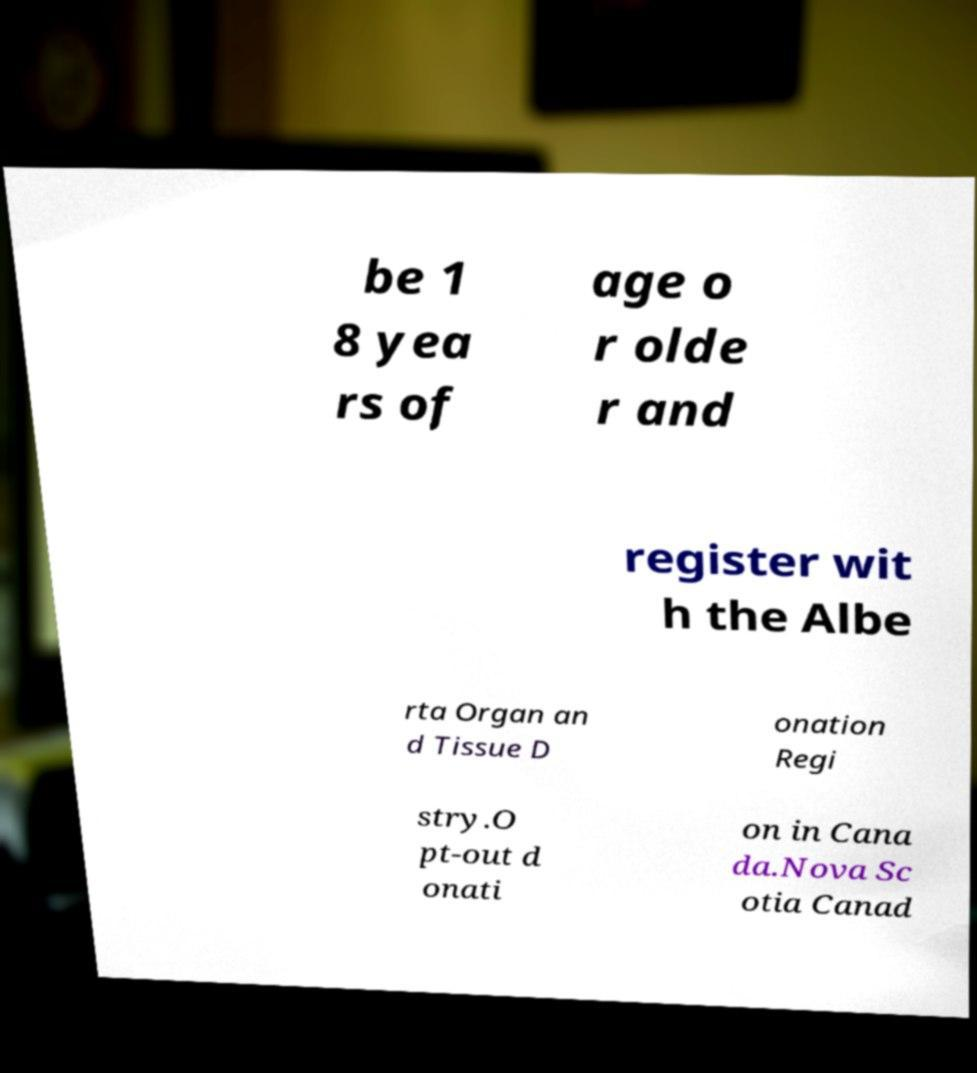For documentation purposes, I need the text within this image transcribed. Could you provide that? be 1 8 yea rs of age o r olde r and register wit h the Albe rta Organ an d Tissue D onation Regi stry.O pt-out d onati on in Cana da.Nova Sc otia Canad 